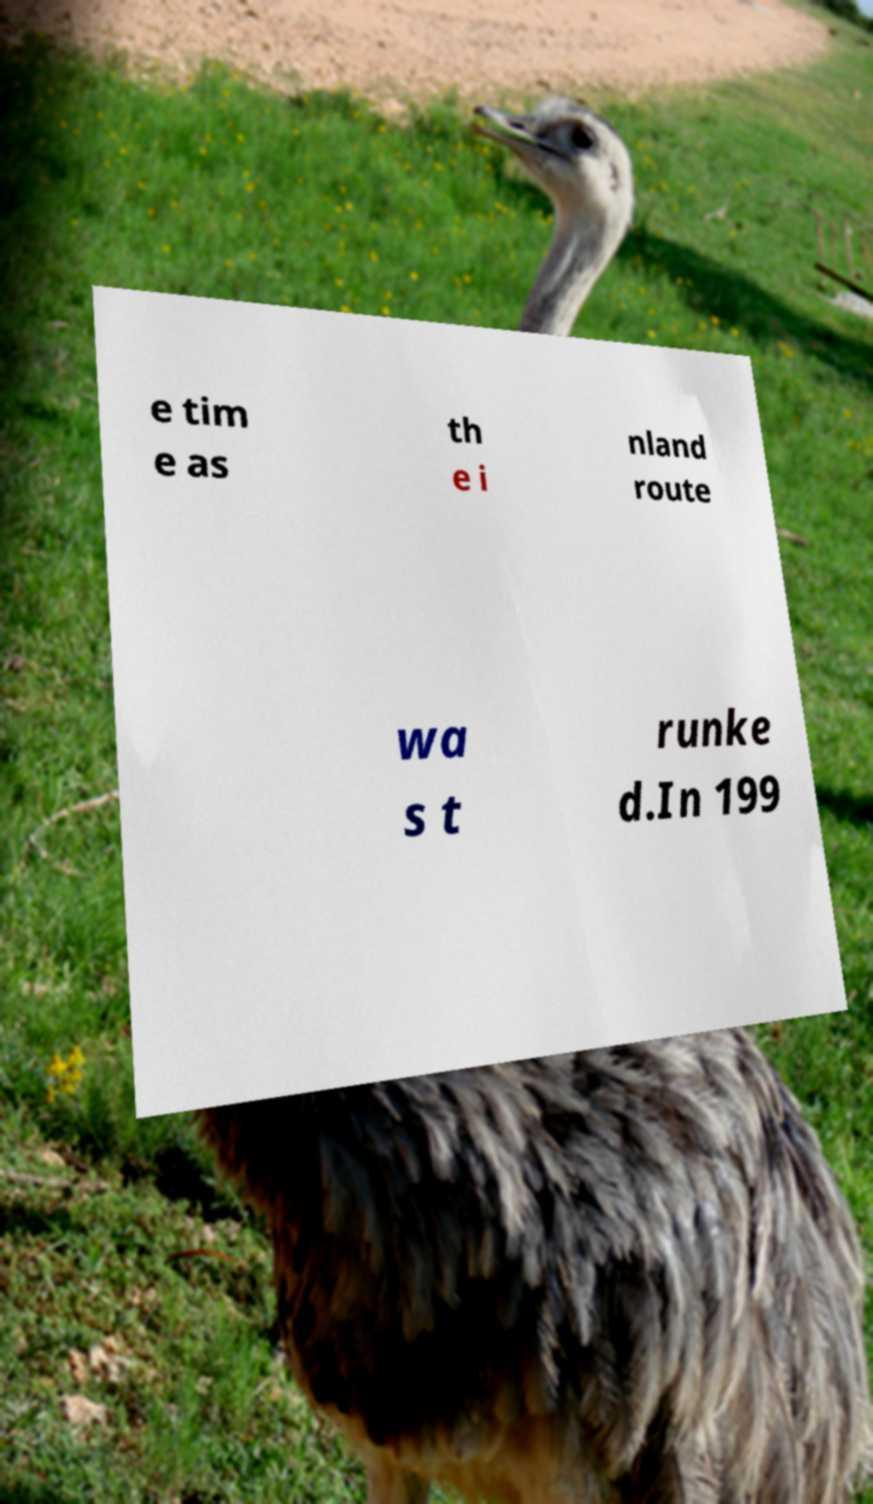Can you accurately transcribe the text from the provided image for me? e tim e as th e i nland route wa s t runke d.In 199 